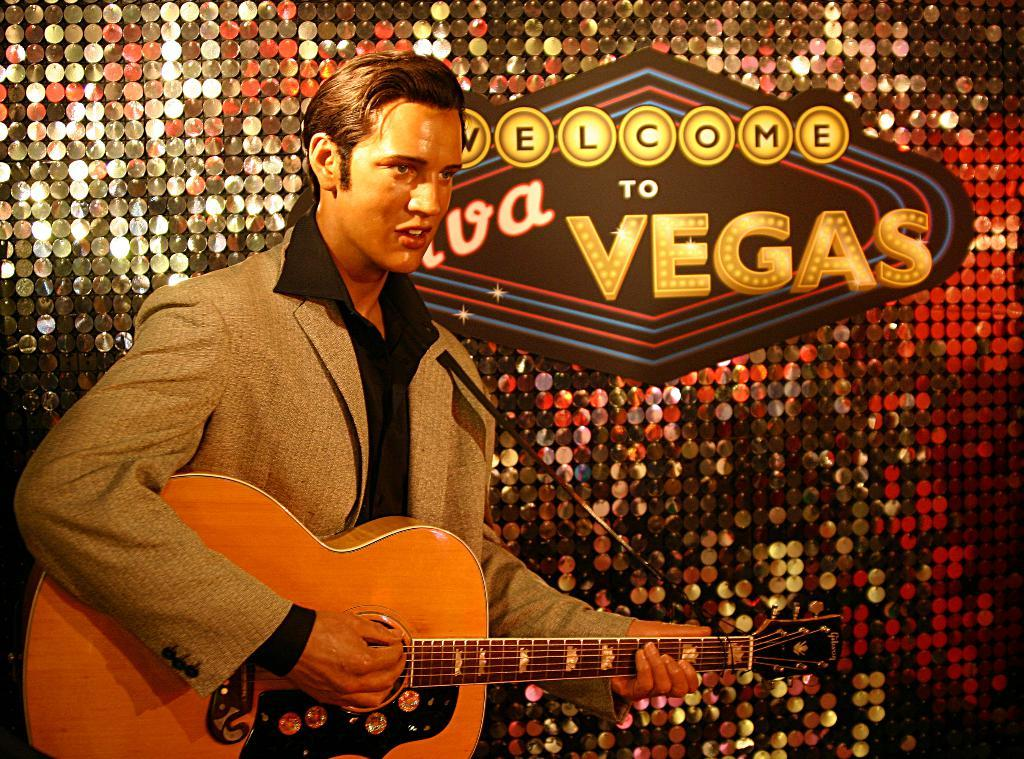What is the main subject of the image? There is a person in the image. What is the person doing in the image? The person is standing and playing a guitar. Can you describe anything in the background of the image? There is a label on the wall in the background. What type of leather is being used to make the agreement in the image? There is no agreement or leather present in the image; it features a person playing a guitar with a label on the wall in the background. 